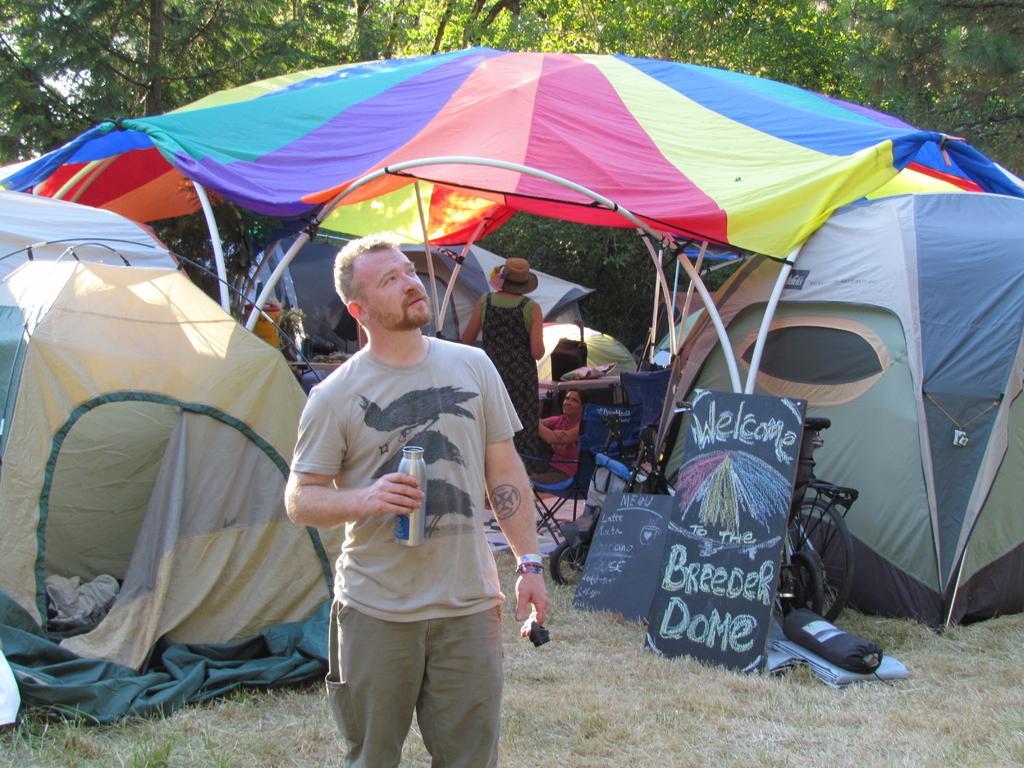Describe this image in one or two sentences. In this image I can see one person is holding bottle. Back I can see few tents, colorful cover, bicycles, blackboards, chairs, trees, grass and few objects on the ground. 